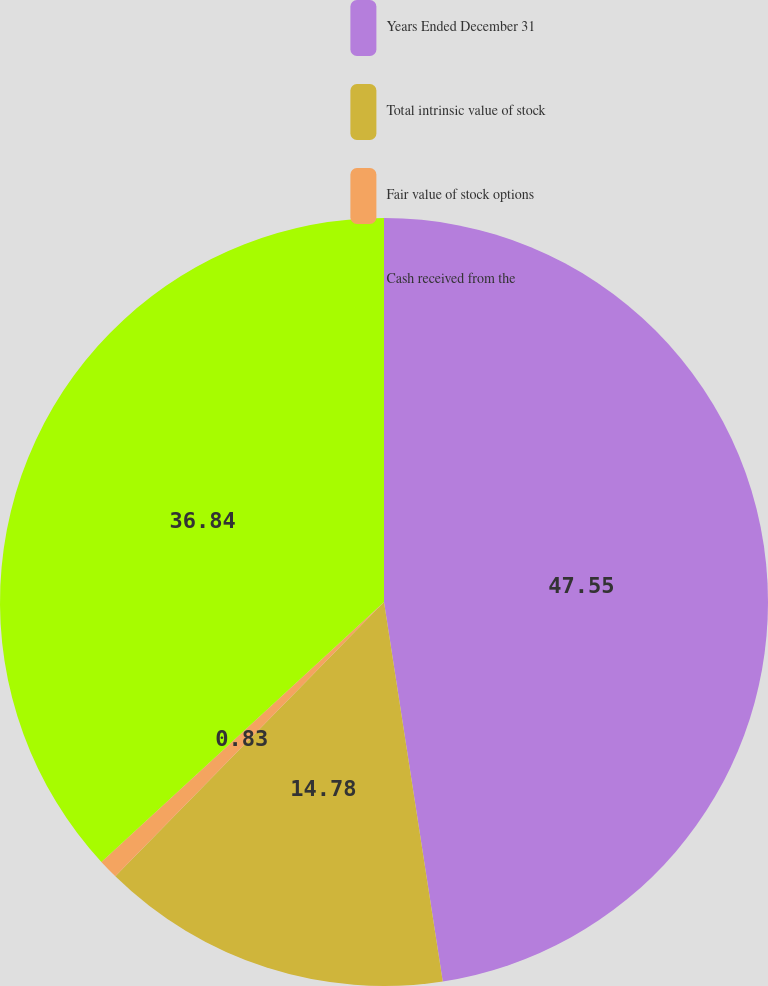Convert chart. <chart><loc_0><loc_0><loc_500><loc_500><pie_chart><fcel>Years Ended December 31<fcel>Total intrinsic value of stock<fcel>Fair value of stock options<fcel>Cash received from the<nl><fcel>47.56%<fcel>14.78%<fcel>0.83%<fcel>36.84%<nl></chart> 